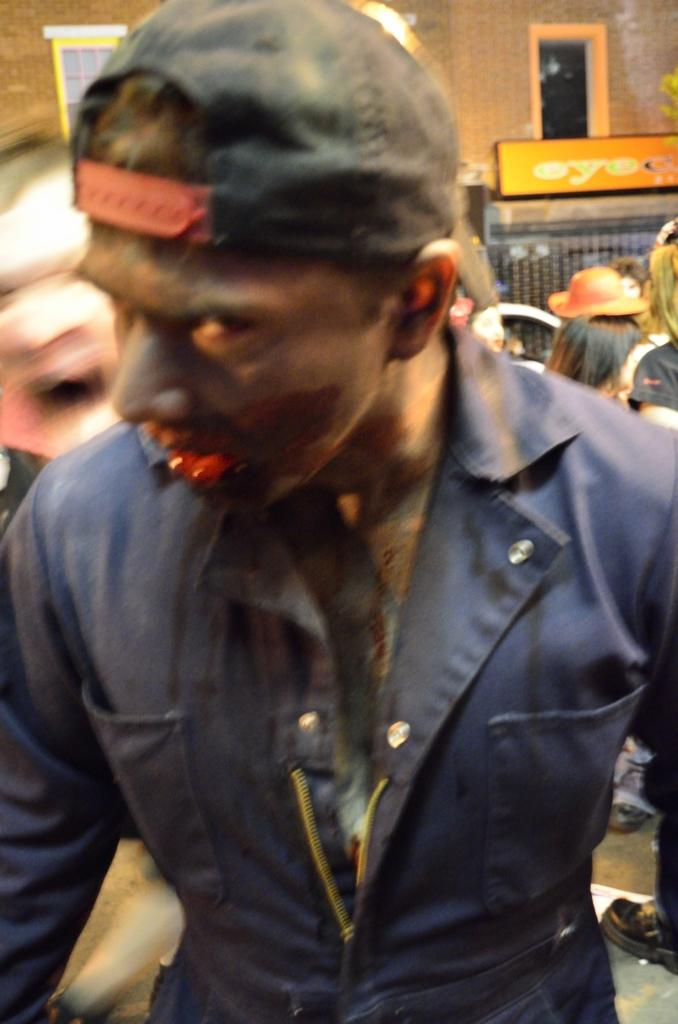What is the man in the image wearing? The man in the image is wearing a black color jacket. What can be seen in the background of the image? There are people, a wall, and a banner in the background of the image. What architectural feature is present in the image? There is a window in the image. How many elements can be identified in the background of the image? There are three elements in the background of the image: people, a wall, and a banner. Is the man in the image changing his clothes while it's raining? There is no indication in the image that the man is changing his clothes or that it is raining. 